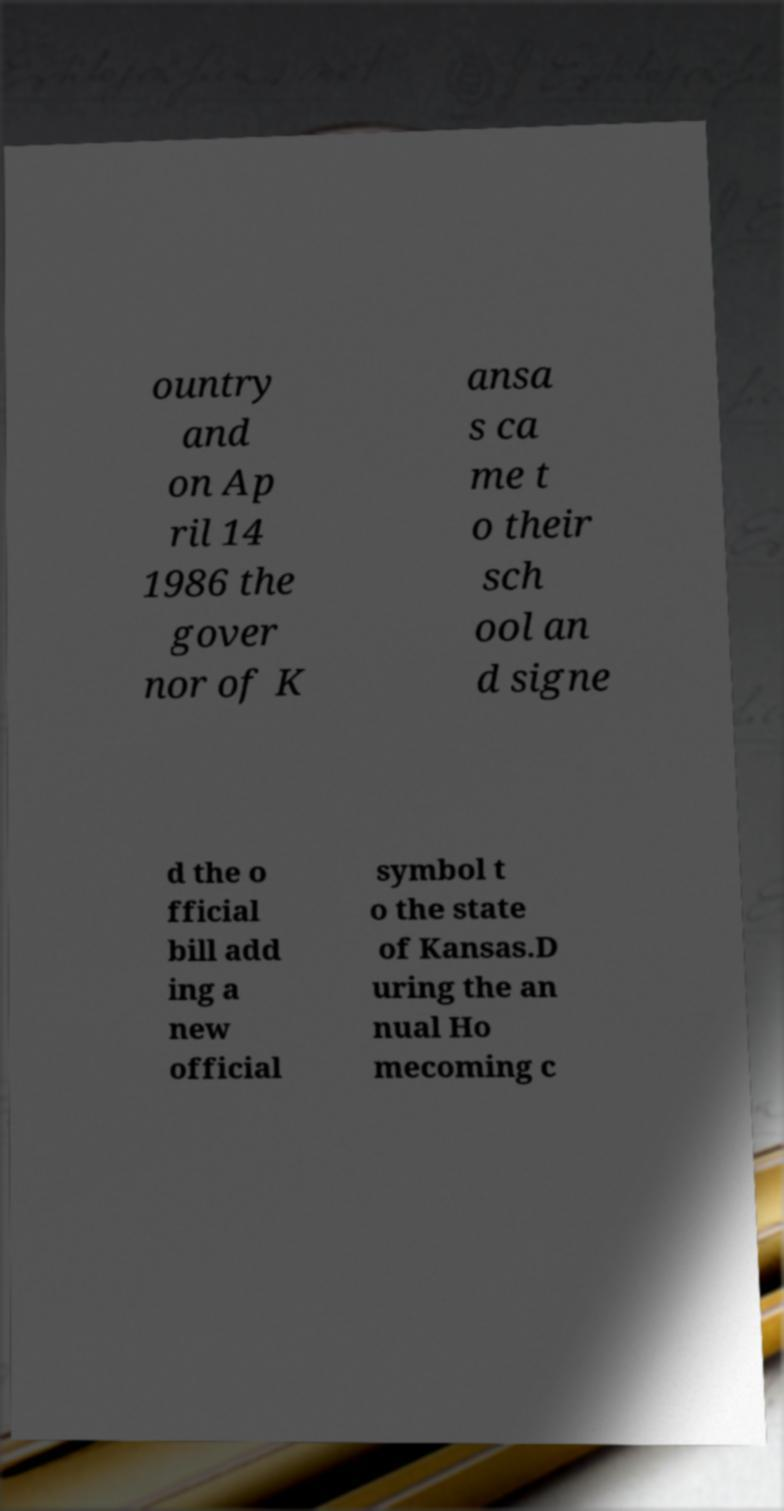Could you assist in decoding the text presented in this image and type it out clearly? ountry and on Ap ril 14 1986 the gover nor of K ansa s ca me t o their sch ool an d signe d the o fficial bill add ing a new official symbol t o the state of Kansas.D uring the an nual Ho mecoming c 